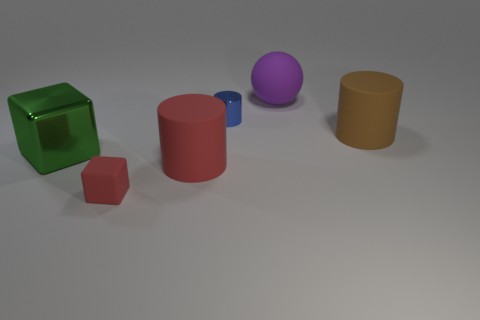Add 1 purple cylinders. How many objects exist? 7 Subtract all cubes. How many objects are left? 4 Subtract 1 blue cylinders. How many objects are left? 5 Subtract all big purple matte balls. Subtract all small cyan things. How many objects are left? 5 Add 6 big brown cylinders. How many big brown cylinders are left? 7 Add 4 small yellow cylinders. How many small yellow cylinders exist? 4 